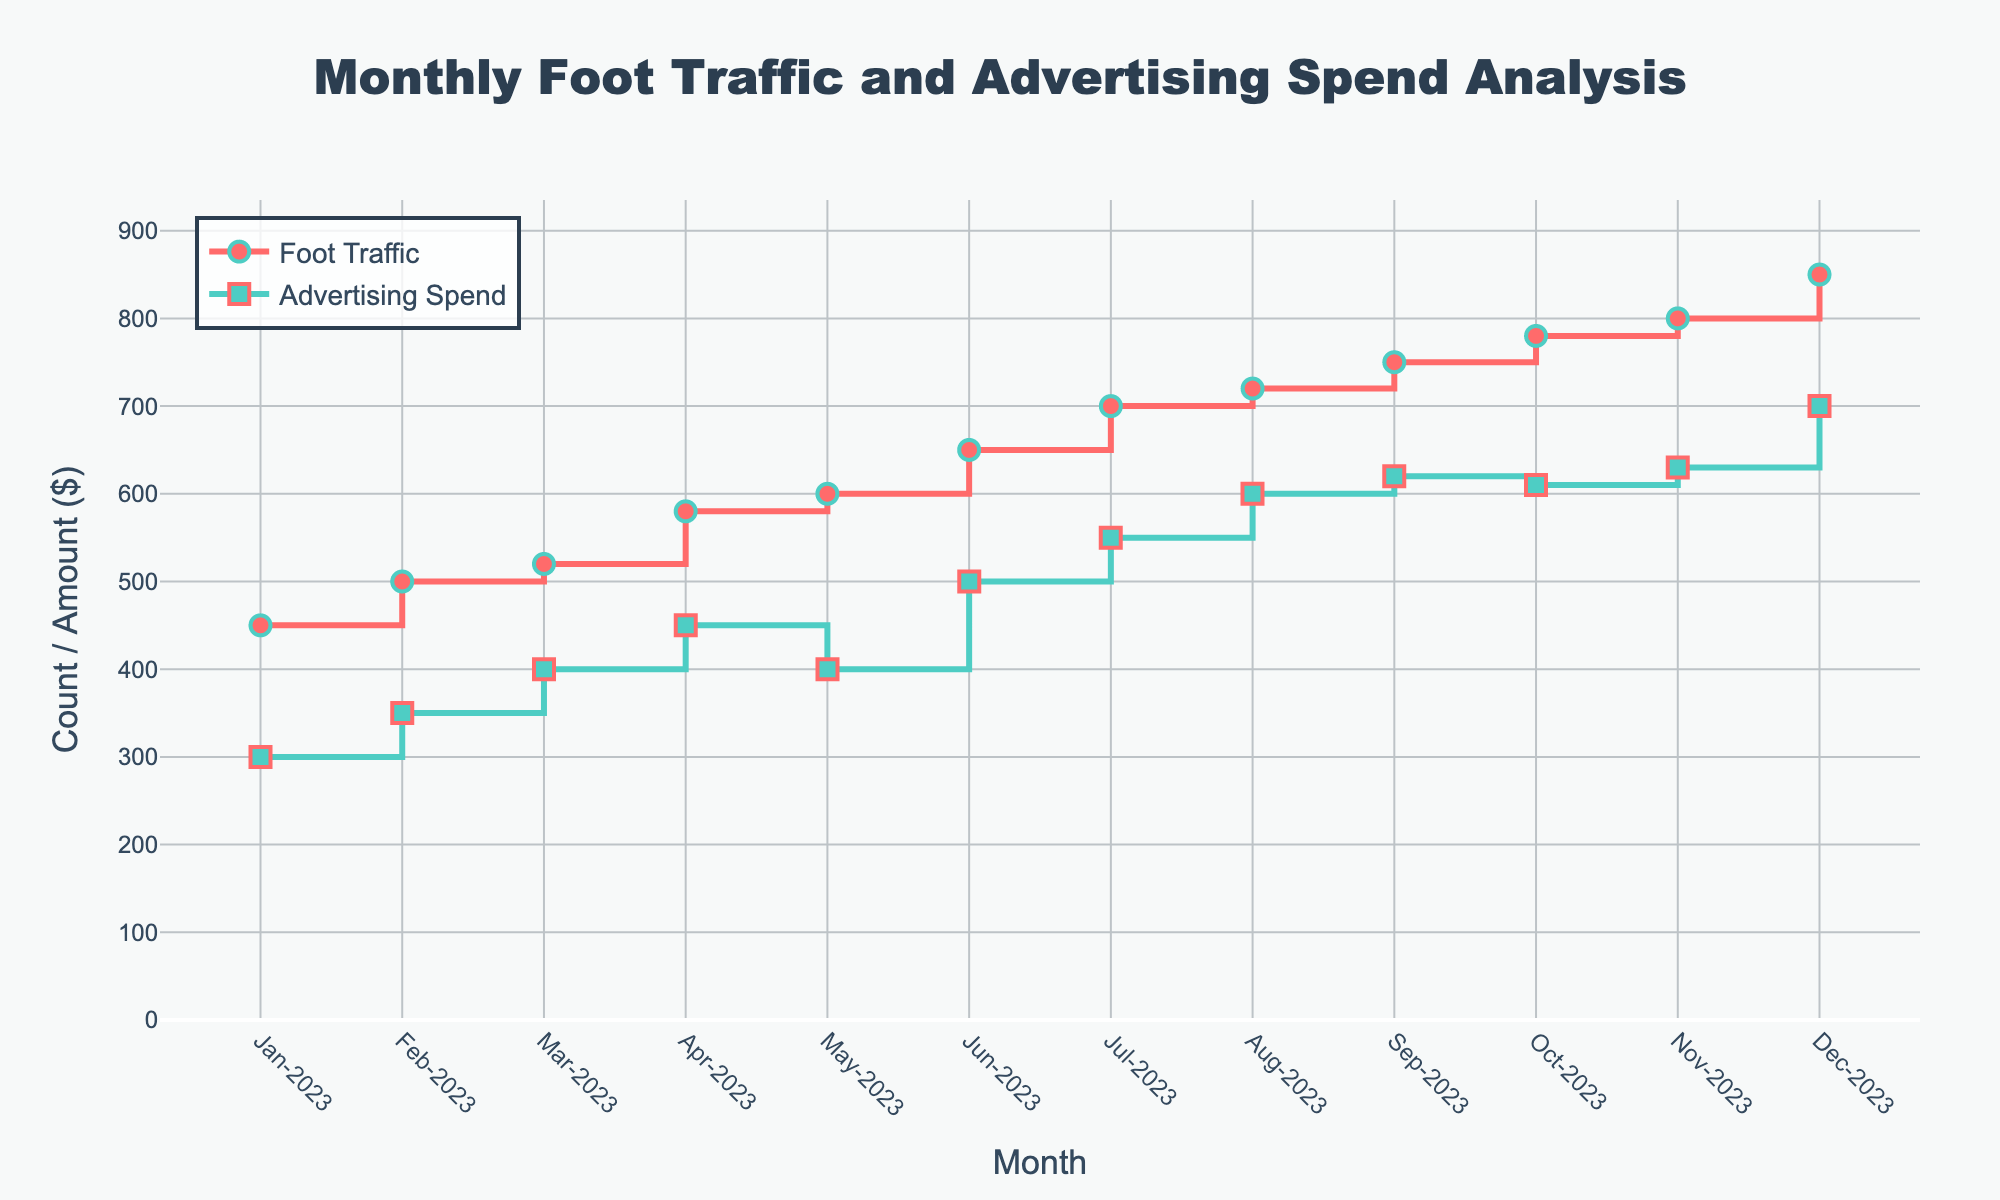How many months of data are displayed in the plot? To determine the number of months of data displayed, count the number of x-axis labels.
Answer: 12 What is the highest value of foot traffic recorded and in which month? To find this, look for the tallest point on the "Foot Traffic" stair plot and note the corresponding month on the x-axis.
Answer: 850 in Dec-2023 Do foot traffic and advertising spend have an increasing trend over time? To answer this, observe the general direction of both stair plots from January to December. Both exhibit an upward trend, indicating an increase over time.
Answer: Yes In which months does advertising spend decrease, if any? Check the "Advertising Spend" stair plot for any downward steps, which indicate a decrease compared to the previous month. May-2023 shows a decrease compared to April-2023 and October-2023 shows a decrease compared to September-2023.
Answer: May-2023, Oct-2023 What's the difference in foot traffic between the month with the highest foot traffic and the month with the lowest? Identify the months with the highest and lowest foot traffic, then subtract the lower value from the higher one (850 - 450).
Answer: 400 Which month shows the largest increase in foot traffic compared to the previous month? Compare the steps in the "Foot Traffic" stair plot to see which month-to-month shift represents the largest increase. Jul-2023 to Aug-2023 shows an increase from 700 to 720, which is 20, the highest.
Answer: Aug-2023 Is the advertising spend in December higher than in any other month? Review the stair plot for "Advertising Spend" and look at all data points. December's value should be compared across all other months to confirm it is the highest value.
Answer: Yes What is the average advertising spend over the year? Calculate the sum of the advertising spend for all months and divide by the number of months (300+350+400+450+400+500+550+600+620+610+630+700)/12.
Answer: 508.33 Compare the advertising spend in the first half of the year (Jan-Jun) versus the second half (Jul-Dec). Which is higher? Sum up the advertising spends for Jan-Jun and Jul-Dec, then compare. Jan-Jun: 2400; Jul-Dec: 3710. The comparison yields that Jul-Dec is higher.
Answer: Jul-Dec 